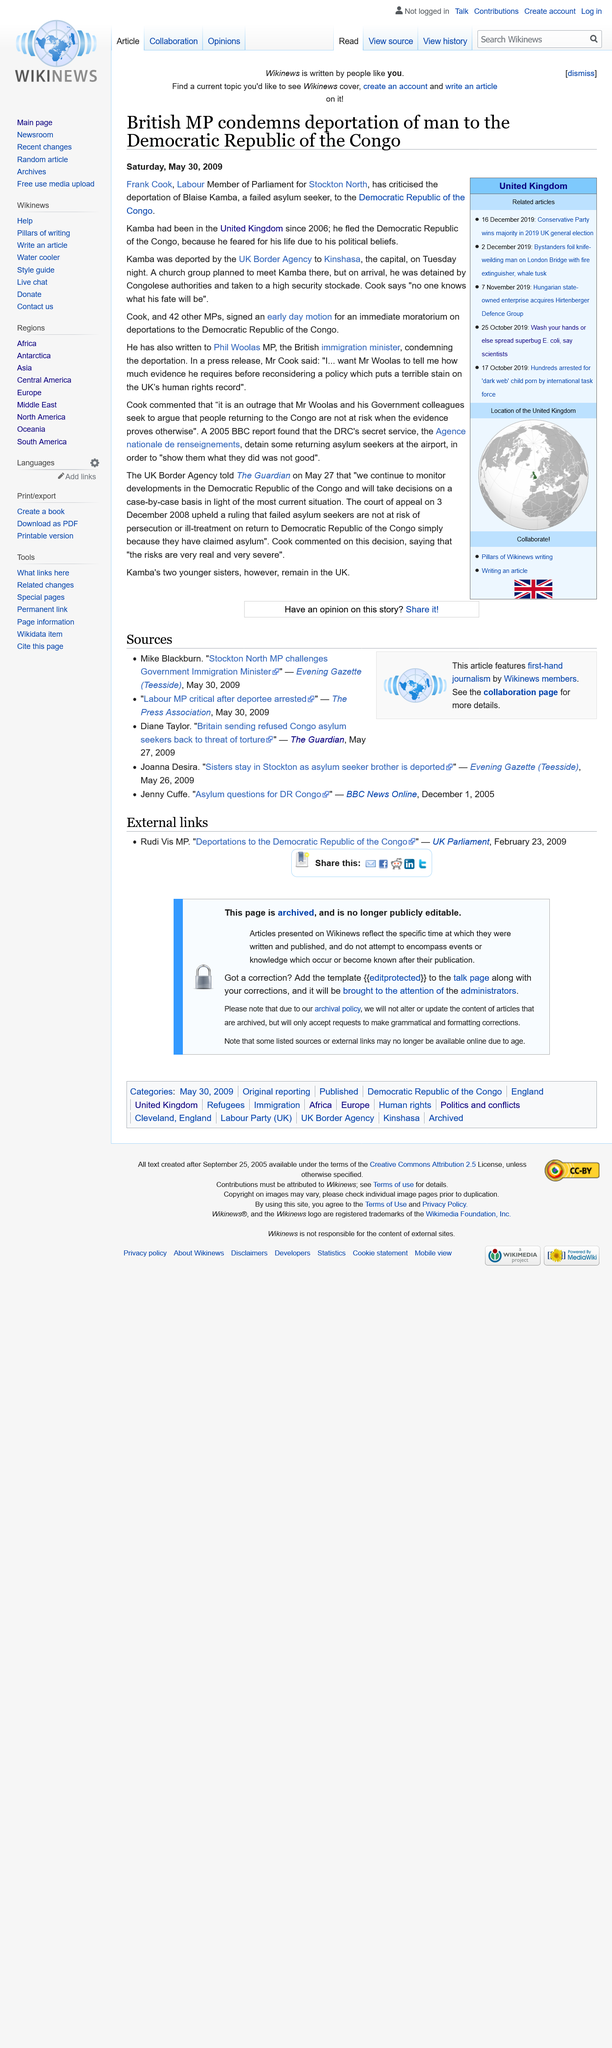Indicate a few pertinent items in this graphic. Kamba was deported by the UK Border Agency. The exact number of MPs who signed an early day motion, besides Frank Cook, was 42. Kamba, a refugee from the Democratic Republic of the Congo, fled his home country to escape the dangerous conditions and seek a better life elsewhere. 